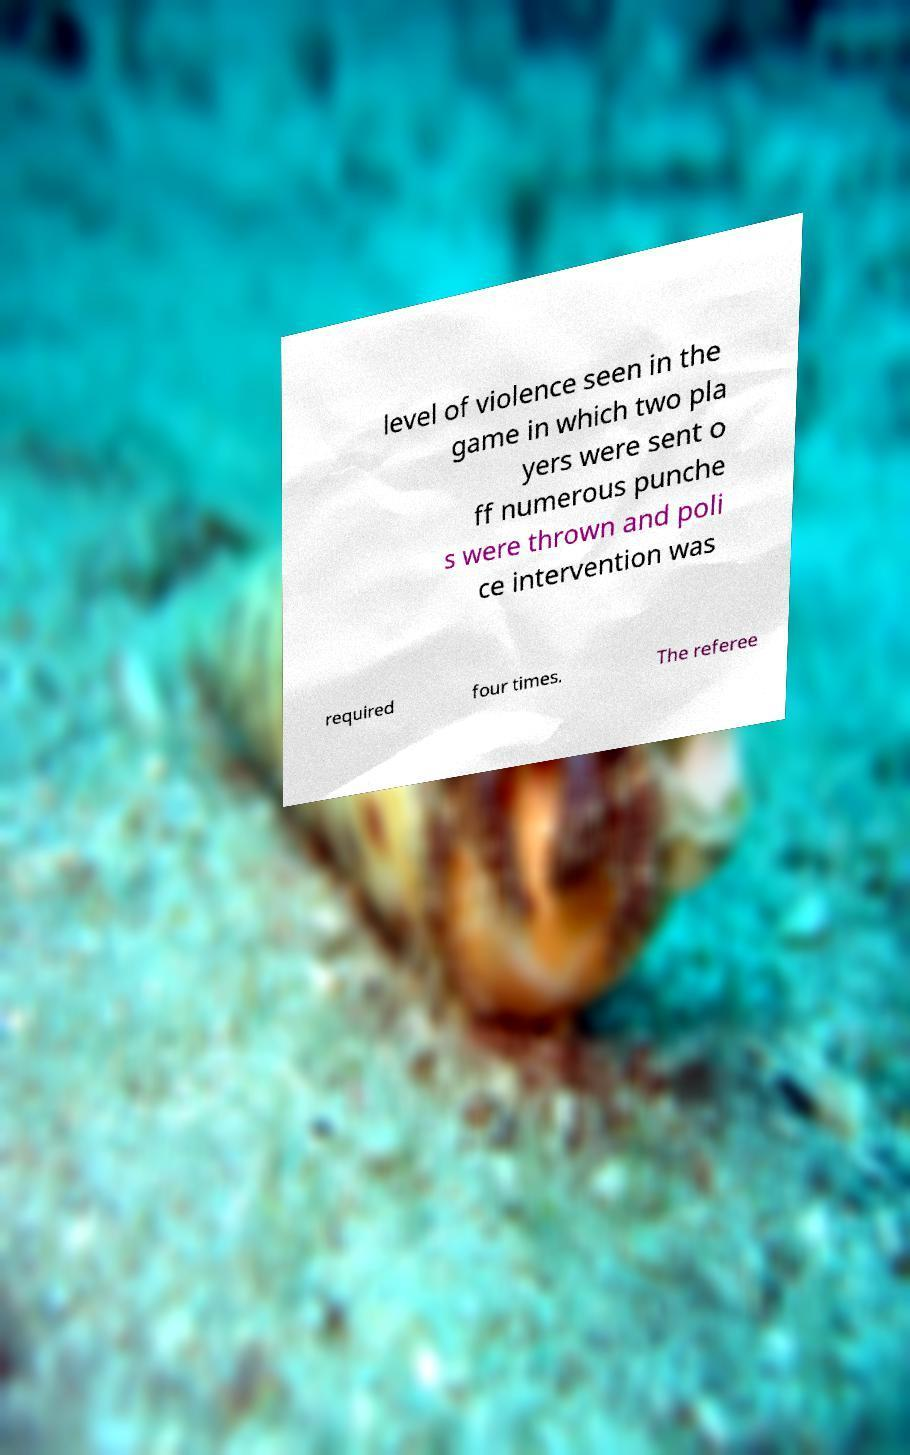There's text embedded in this image that I need extracted. Can you transcribe it verbatim? level of violence seen in the game in which two pla yers were sent o ff numerous punche s were thrown and poli ce intervention was required four times. The referee 